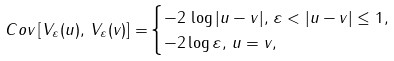Convert formula to latex. <formula><loc_0><loc_0><loc_500><loc_500>{ C o v } \left [ V _ { \varepsilon } ( u ) , \, V _ { \varepsilon } ( v ) \right ] = & \begin{cases} - 2 \, \log | u - v | , \, \varepsilon < | u - v | \leq 1 , \\ - 2 \log \varepsilon , \, u = v , \end{cases}</formula> 